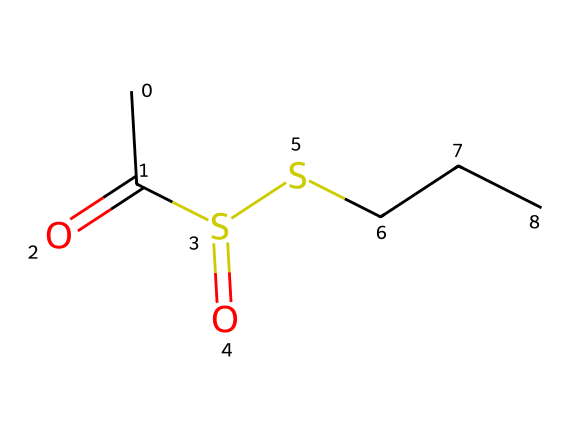What is the main functional group in this compound? The chemical structure contains a sulfonyl group (S=O) and a thioether (S-), indicating that it is primarily characterized by organosulfur functional groups.
Answer: sulfonyl How many carbon atoms are present in this chemical structure? By examining the structure, we can count the carbon atoms: there are three carbon (C) atoms in the aliphatic chain attached to sulfur, plus one in the acetyl group, totaling four carbon atoms.
Answer: four What does the presence of sulfur atoms suggest about the properties of this compound? Sulfur typically imparts strong odors and flavors, and in organosulfur compounds like allicin, it is responsible for the distinct aroma found in garlic, enhancing pungency and potential biological activities.
Answer: distinct aroma What type of reaction is likely responsible for the formation of allicin from garlic? Allicin is formed through enzymatic reactions when garlic is chopped or crushed, leading to the conversion of alliin into allicin, highlighting the reactivity of sulfur in its formation.
Answer: enzymatic reaction How many sulfur atoms are in this chemical? In the SMILES representation, there are two sulfur (S) atoms present, as indicated in the structure where each sulfur is connected to other atoms, showing its role in the compound.
Answer: two Is allicin stable or unstable under heat when used in cooking? Allicin tends to be unstable at high temperatures, which means it can decompose and lose its properties when exposed to heat during cooking.
Answer: unstable 